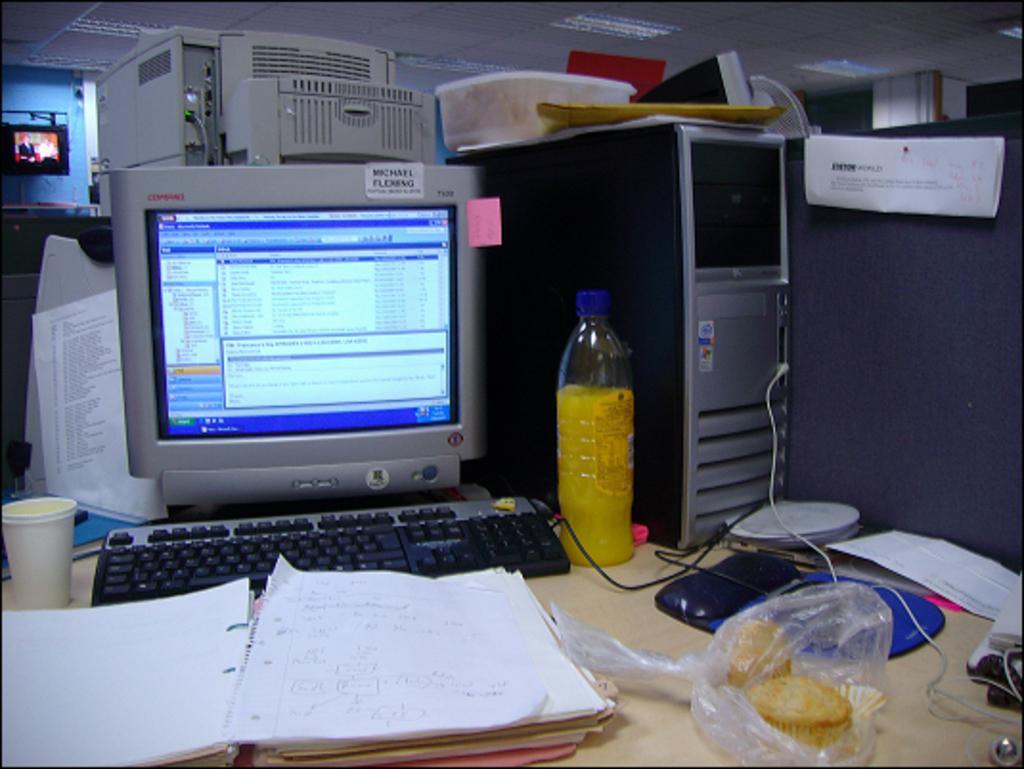Can you describe this image briefly? In this image I can see a system,papers,cup,food,bottle on the table. In the background there is a screen. 